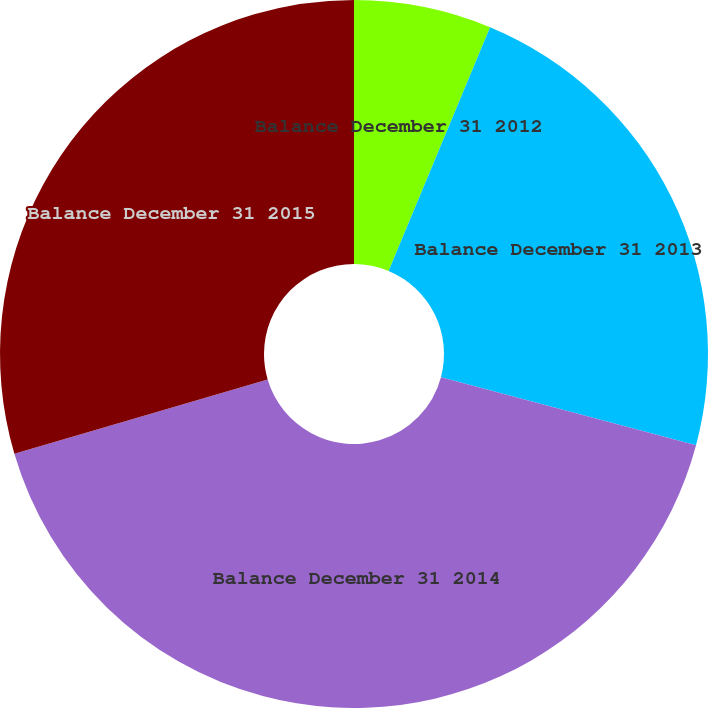<chart> <loc_0><loc_0><loc_500><loc_500><pie_chart><fcel>Balance December 31 2012<fcel>Balance December 31 2013<fcel>Balance December 31 2014<fcel>Balance December 31 2015<nl><fcel>6.28%<fcel>22.87%<fcel>41.3%<fcel>29.55%<nl></chart> 